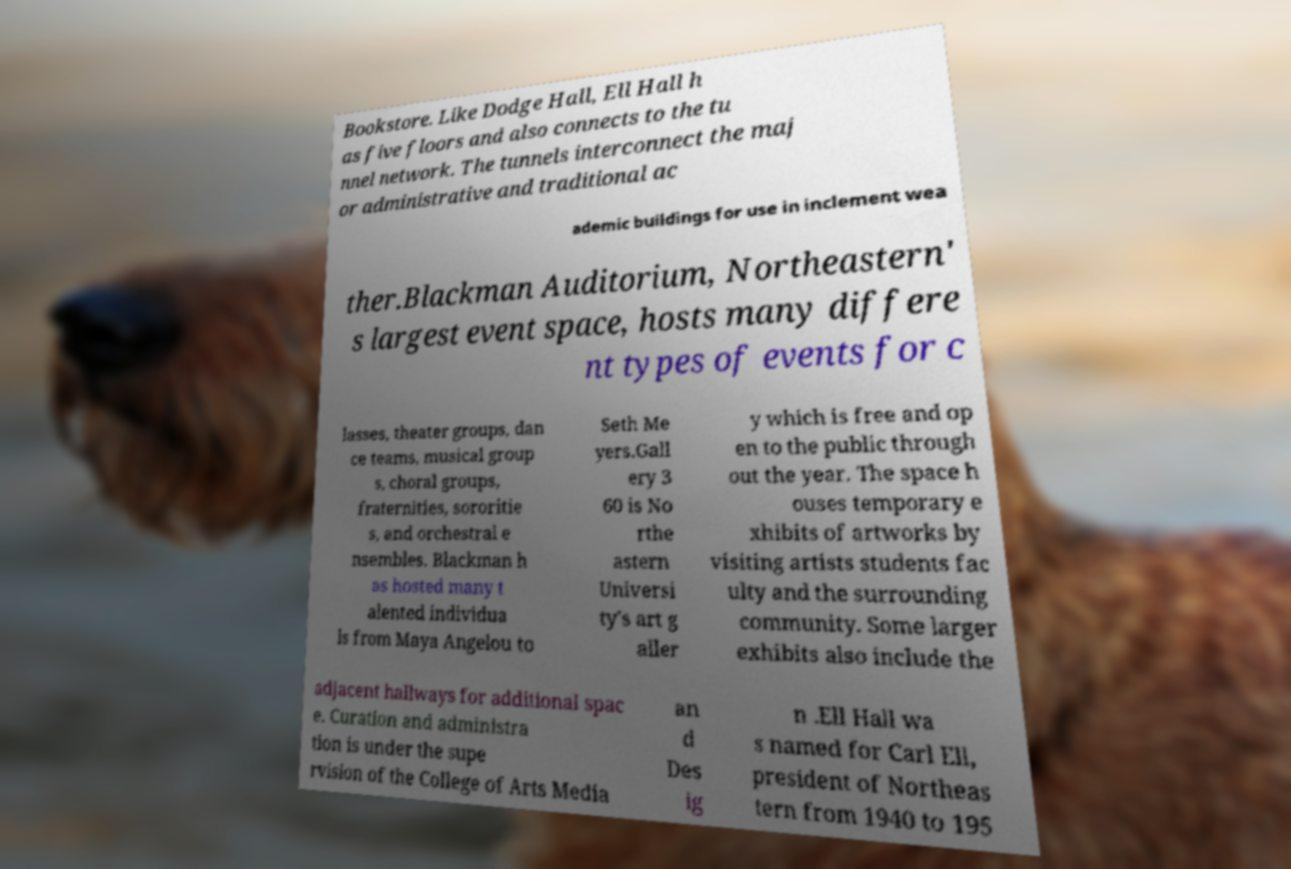There's text embedded in this image that I need extracted. Can you transcribe it verbatim? Bookstore. Like Dodge Hall, Ell Hall h as five floors and also connects to the tu nnel network. The tunnels interconnect the maj or administrative and traditional ac ademic buildings for use in inclement wea ther.Blackman Auditorium, Northeastern' s largest event space, hosts many differe nt types of events for c lasses, theater groups, dan ce teams, musical group s, choral groups, fraternities, sororitie s, and orchestral e nsembles. Blackman h as hosted many t alented individua ls from Maya Angelou to Seth Me yers.Gall ery 3 60 is No rthe astern Universi ty's art g aller y which is free and op en to the public through out the year. The space h ouses temporary e xhibits of artworks by visiting artists students fac ulty and the surrounding community. Some larger exhibits also include the adjacent hallways for additional spac e. Curation and administra tion is under the supe rvision of the College of Arts Media an d Des ig n .Ell Hall wa s named for Carl Ell, president of Northeas tern from 1940 to 195 